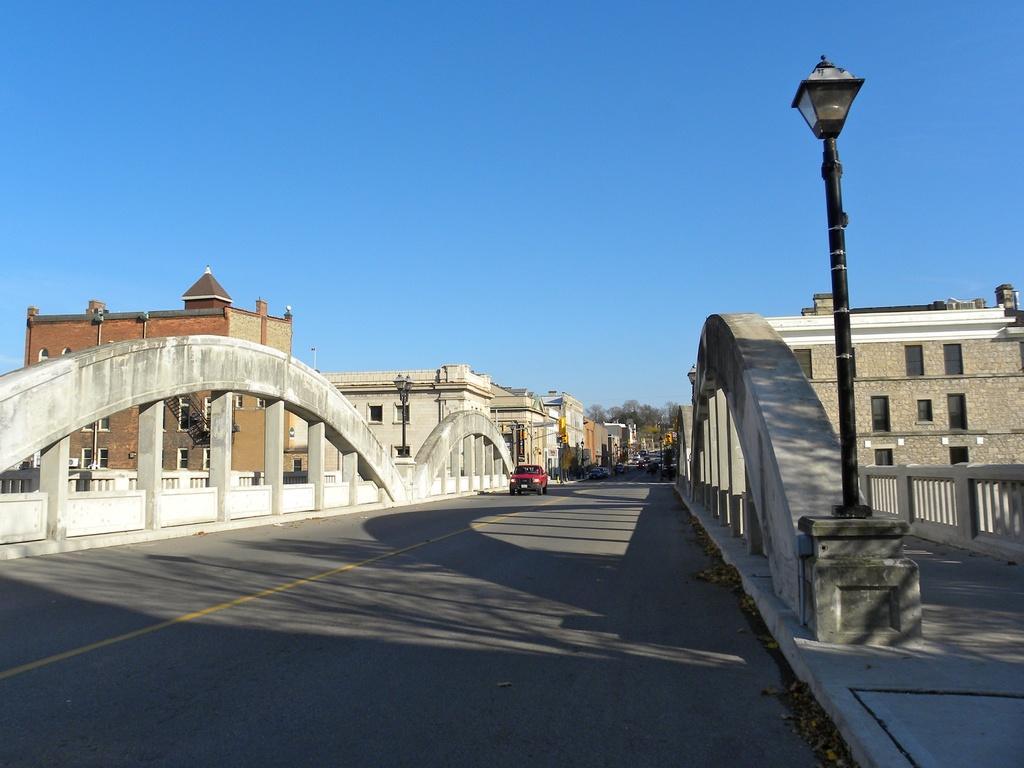Describe this image in one or two sentences. In this image we can see buildings, motor vehicles on the road, staircases, railings, street poles, street lights, trees and sky. 